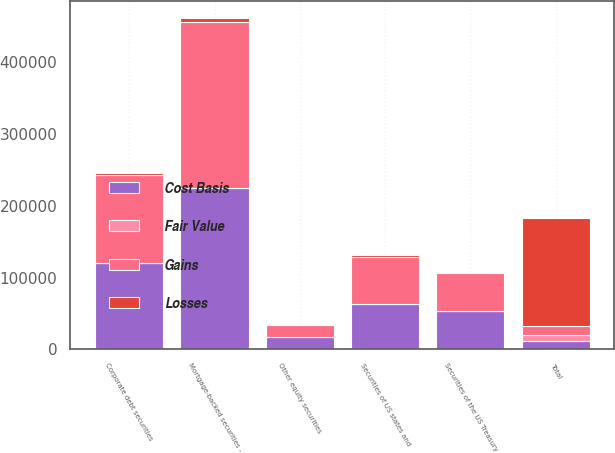Convert chart to OTSL. <chart><loc_0><loc_0><loc_500><loc_500><stacked_bar_chart><ecel><fcel>Securities of US states and<fcel>Securities of the US Treasury<fcel>Corporate debt securities<fcel>Mortgage-backed securities -<fcel>Other equity securities<fcel>Total<nl><fcel>Cost Basis<fcel>62674<fcel>52909<fcel>120159<fcel>225443<fcel>16534<fcel>12084.5<nl><fcel>Losses<fcel>2815<fcel>791<fcel>2949<fcel>5603<fcel>666<fcel>151777<nl><fcel>Fair Value<fcel>0<fcel>0<fcel>0<fcel>0<fcel>111<fcel>7635<nl><fcel>Gains<fcel>65489<fcel>53700<fcel>123108<fcel>231046<fcel>17089<fcel>12084.5<nl></chart> 